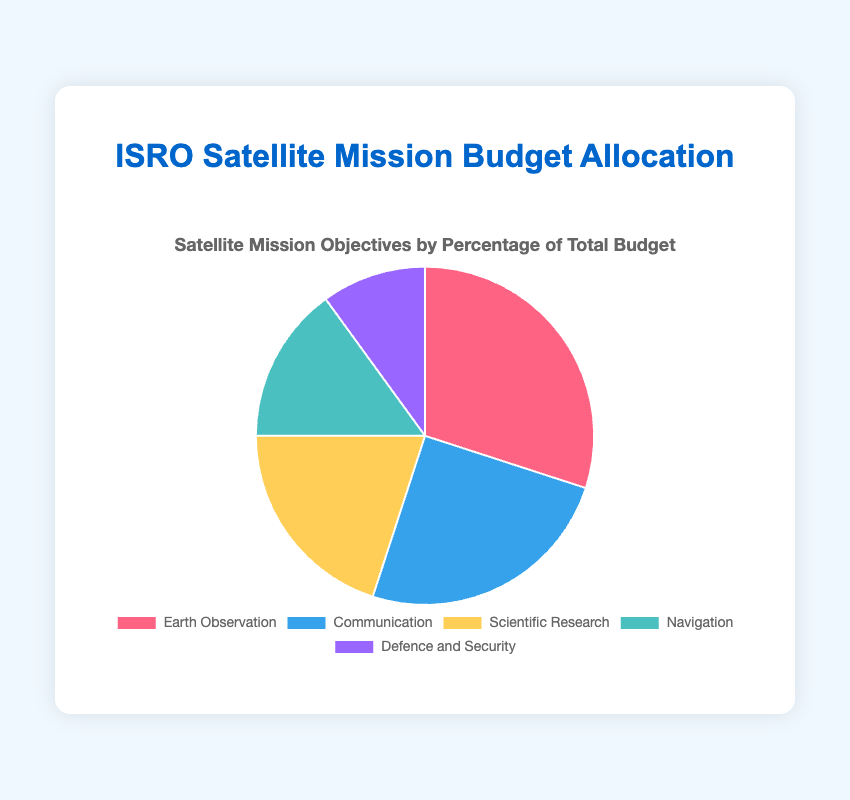Which mission objective received the highest percentage of the total budget? The pie chart shows that 'Earth Observation' received 30% of the total budget, the highest among all the objectives.
Answer: Earth Observation How much greater is the percentage allocated to Communication missions compared to Defence and Security missions? The percentage for Communication missions is 25%, while Defence and Security missions receive 10%. The difference is calculated by subtracting 10% from 25%.
Answer: 15% What is the combined budget percentage for Scientific Research and Navigation missions? Add the percentages for Scientific Research (20%) and Navigation (15%) missions. 20% + 15% = 35%.
Answer: 35% Is the budget percentage for Earth Observation greater than the aggregate budget percentage for Navigation and Defence and Security missions? The budget percentage for Earth Observation is 30%. For combined Navigation and Defence and Security, it is 15% + 10% = 25%. Compare 30% and 25%.
Answer: Yes Rank the mission objectives from highest to lowest budget percentage. The visual shows the following percentages: Earth Observation (30%), Communication (25%), Scientific Research (20%), Navigation (15%), Defence and Security (10%). Rank them accordingly.
Answer: Earth Observation, Communication, Scientific Research, Navigation, Defence and Security What is the difference between the budget percentages of the largest and smallest mission objectives? The largest is Earth Observation (30%) and the smallest is Defence and Security (10%). Subtract 10% from 30%.
Answer: 20% What's the average budget percentage allocated per mission objective? Sum all the percentages: 30% + 25% + 20% + 15% + 10% = 100%. Divide by the number of objectives (5). 100% / 5 = 20%.
Answer: 20% Which mission objective has a lower budget percentage: Navigation or Scientific Research? The chart shows that Navigation has 15% and Scientific Research has 20%. Compare the two.
Answer: Navigation What percentage of the budget is allocated to mission objectives other than Communication and Earth Observation? Sum the percentages for Scientific Research, Navigation, and Defence and Security: 20% + 15% + 10% = 45%.
Answer: 45% What is the color used to represent the Communication mission objective? Based on the pie chart's legend, Communication is represented in blue color.
Answer: Blue 